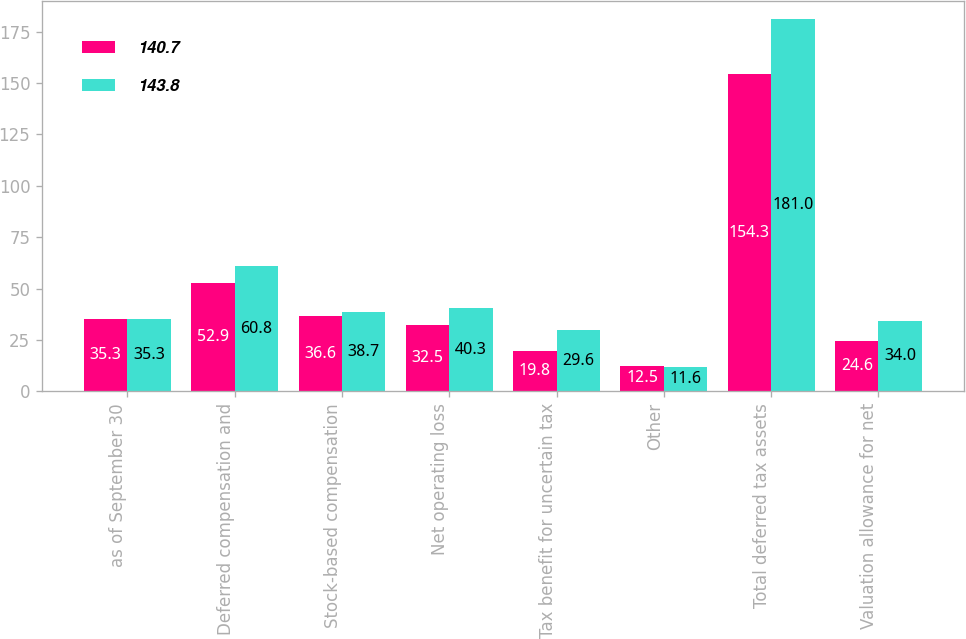Convert chart to OTSL. <chart><loc_0><loc_0><loc_500><loc_500><stacked_bar_chart><ecel><fcel>as of September 30<fcel>Deferred compensation and<fcel>Stock-based compensation<fcel>Net operating loss<fcel>Tax benefit for uncertain tax<fcel>Other<fcel>Total deferred tax assets<fcel>Valuation allowance for net<nl><fcel>140.7<fcel>35.3<fcel>52.9<fcel>36.6<fcel>32.5<fcel>19.8<fcel>12.5<fcel>154.3<fcel>24.6<nl><fcel>143.8<fcel>35.3<fcel>60.8<fcel>38.7<fcel>40.3<fcel>29.6<fcel>11.6<fcel>181<fcel>34<nl></chart> 